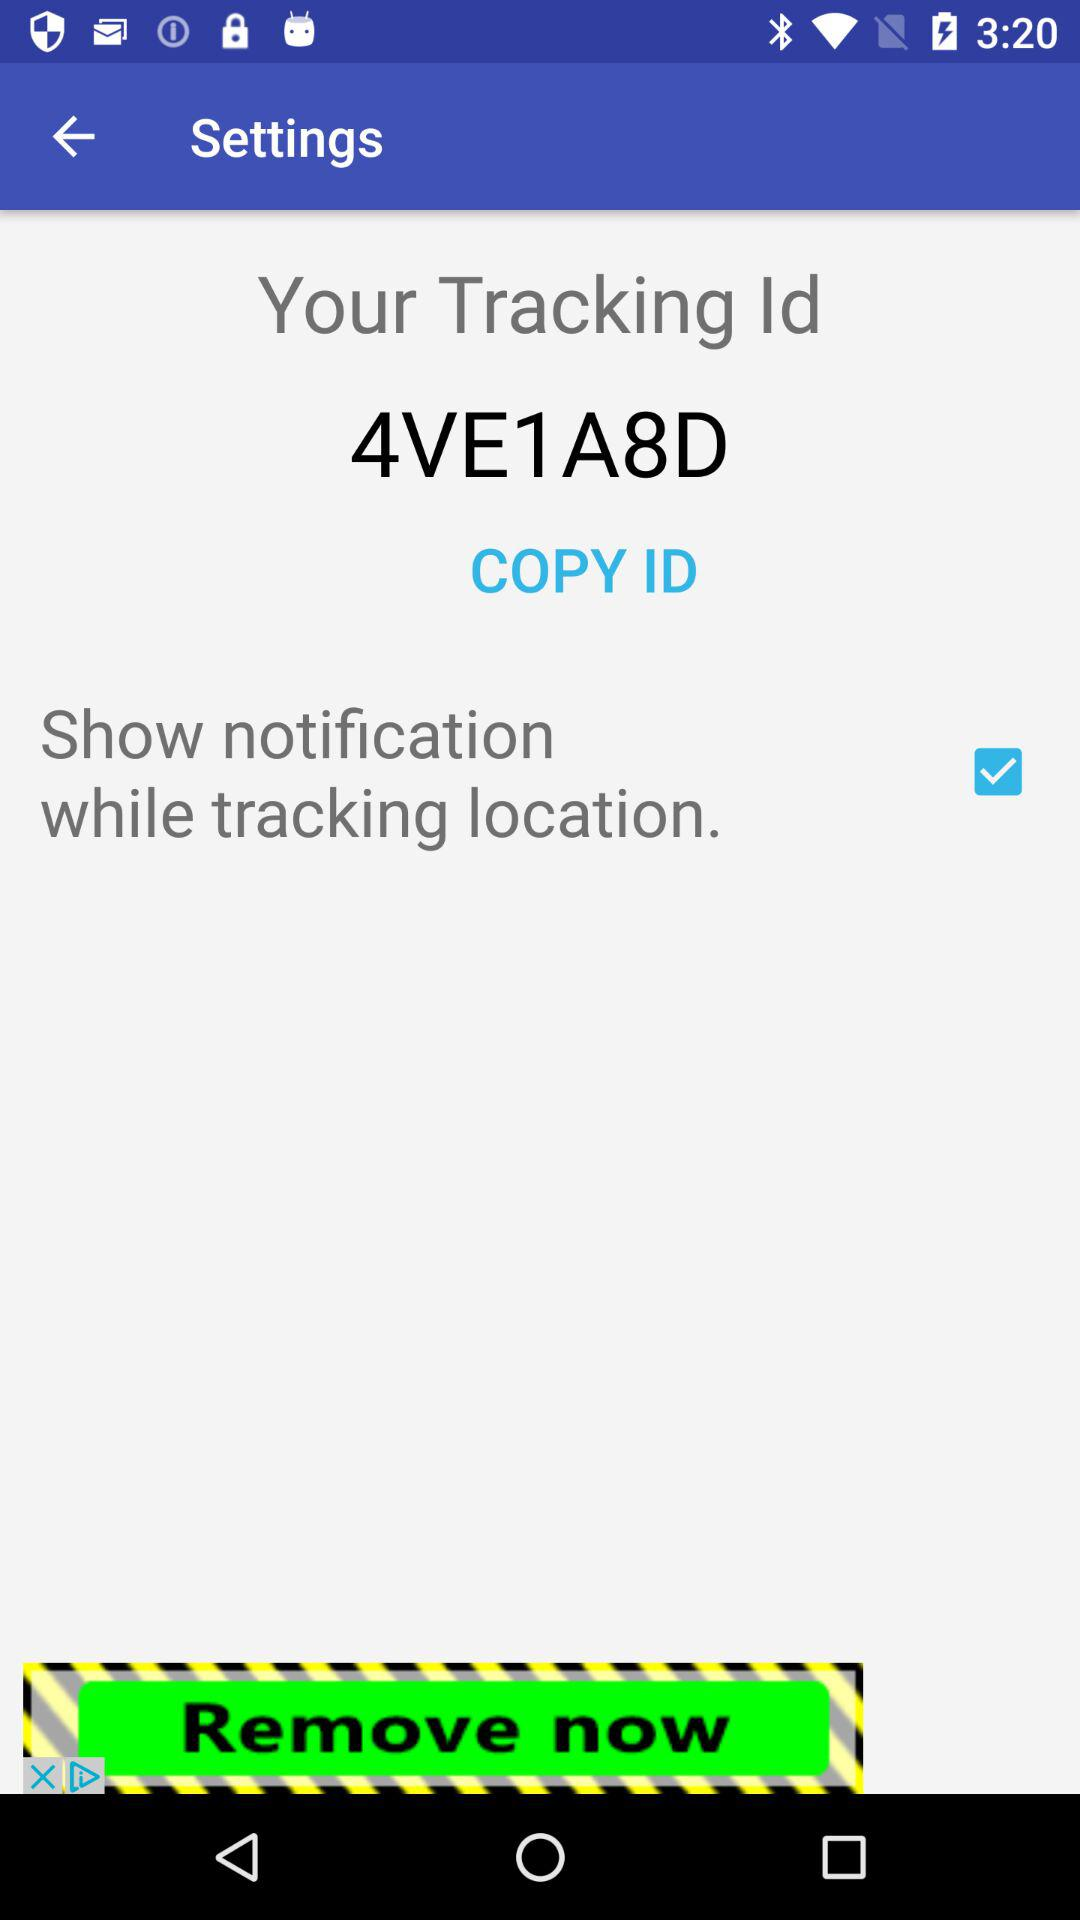When was the tracking ID sent?
When the provided information is insufficient, respond with <no answer>. <no answer> 